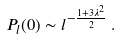<formula> <loc_0><loc_0><loc_500><loc_500>P _ { l } ( 0 ) \sim l ^ { - \frac { 1 + 3 \lambda ^ { 2 } } { 2 } } \, .</formula> 